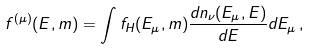<formula> <loc_0><loc_0><loc_500><loc_500>f ^ { ( \mu ) } ( E , m ) = \int f _ { H } ( E _ { \mu } , m ) \frac { d n _ { \nu } ( E _ { \mu } , E ) } { d E } d E _ { \mu } \, ,</formula> 